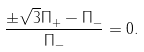<formula> <loc_0><loc_0><loc_500><loc_500>\frac { \pm \sqrt { 3 } \Pi _ { + } - \Pi _ { - } } { \Pi _ { - } } = 0 .</formula> 